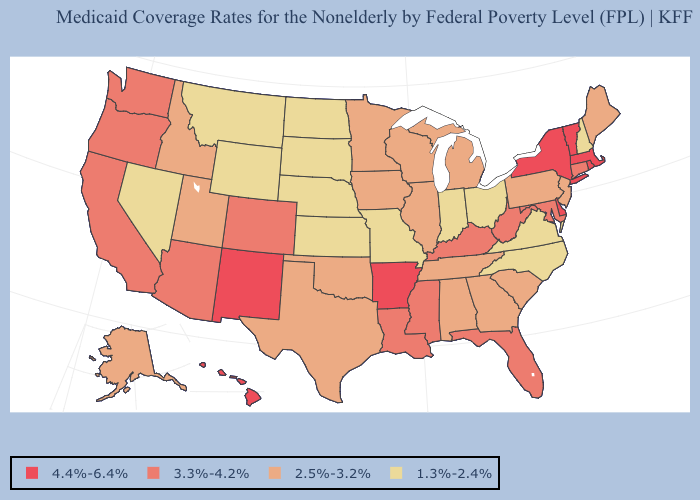Does Rhode Island have a higher value than Texas?
Give a very brief answer. Yes. Name the states that have a value in the range 2.5%-3.2%?
Give a very brief answer. Alabama, Alaska, Georgia, Idaho, Illinois, Iowa, Maine, Michigan, Minnesota, New Jersey, Oklahoma, Pennsylvania, South Carolina, Tennessee, Texas, Utah, Wisconsin. What is the value of Kansas?
Be succinct. 1.3%-2.4%. Which states have the lowest value in the USA?
Answer briefly. Indiana, Kansas, Missouri, Montana, Nebraska, Nevada, New Hampshire, North Carolina, North Dakota, Ohio, South Dakota, Virginia, Wyoming. Does Alaska have a higher value than Colorado?
Short answer required. No. How many symbols are there in the legend?
Give a very brief answer. 4. Does the map have missing data?
Write a very short answer. No. Name the states that have a value in the range 1.3%-2.4%?
Answer briefly. Indiana, Kansas, Missouri, Montana, Nebraska, Nevada, New Hampshire, North Carolina, North Dakota, Ohio, South Dakota, Virginia, Wyoming. Which states have the lowest value in the USA?
Concise answer only. Indiana, Kansas, Missouri, Montana, Nebraska, Nevada, New Hampshire, North Carolina, North Dakota, Ohio, South Dakota, Virginia, Wyoming. Name the states that have a value in the range 1.3%-2.4%?
Short answer required. Indiana, Kansas, Missouri, Montana, Nebraska, Nevada, New Hampshire, North Carolina, North Dakota, Ohio, South Dakota, Virginia, Wyoming. What is the value of Iowa?
Be succinct. 2.5%-3.2%. Does Oregon have the lowest value in the USA?
Quick response, please. No. Name the states that have a value in the range 2.5%-3.2%?
Be succinct. Alabama, Alaska, Georgia, Idaho, Illinois, Iowa, Maine, Michigan, Minnesota, New Jersey, Oklahoma, Pennsylvania, South Carolina, Tennessee, Texas, Utah, Wisconsin. Name the states that have a value in the range 1.3%-2.4%?
Be succinct. Indiana, Kansas, Missouri, Montana, Nebraska, Nevada, New Hampshire, North Carolina, North Dakota, Ohio, South Dakota, Virginia, Wyoming. What is the value of Kansas?
Be succinct. 1.3%-2.4%. 